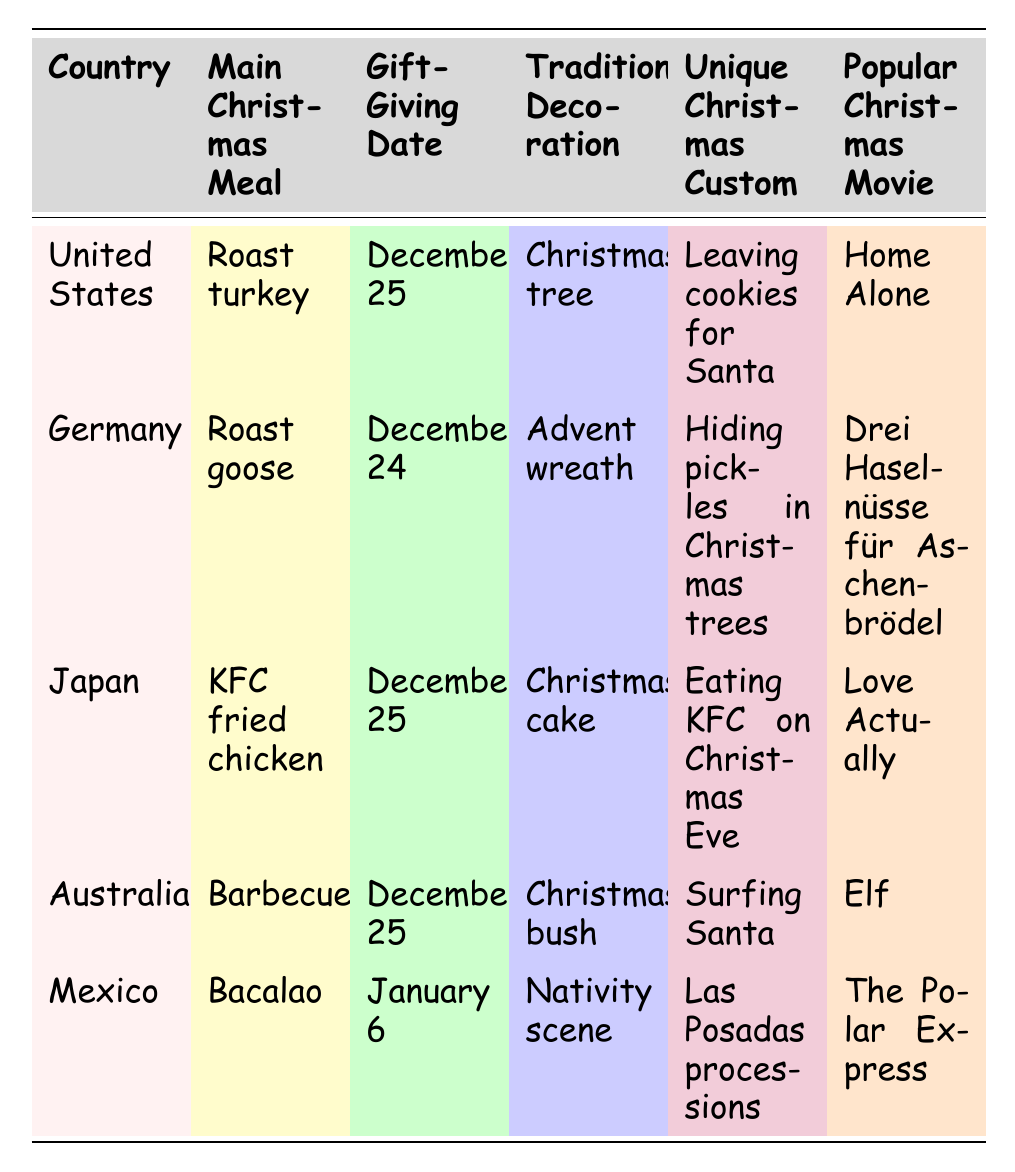What is the main Christmas meal in Germany? The table lists Germany's main Christmas meal as roast goose.
Answer: Roast goose On which date is Christmas gift-giving celebrated in Australia? According to the table, Australia celebrates gift-giving on December 25.
Answer: December 25 What unique Christmas custom does Japan have? The table states that Japan's unique Christmas custom is eating KFC on Christmas Eve.
Answer: Eating KFC on Christmas Eve Which country has a Christmas tree as their traditional decoration? The table shows that the United States uses a Christmas tree as their traditional decoration.
Answer: United States How many countries celebrate gift-giving on December 25? The countries celebrating on December 25 are the United States, Japan, and Australia, totaling three countries.
Answer: Three Is "Las Posadas processions" a unique Christmas custom in Mexico? Yes, the table confirms that "Las Posadas processions" is indeed a unique custom in Mexico.
Answer: Yes Which popular Christmas movie is associated with Germany? From the table, the popular Christmas movie associated with Germany is "Drei Haselnüsse für Aschenbrödel."
Answer: Drei Haselnüsse für Aschenbrödel What is the difference in gift-giving dates between Germany and Mexico? Germany celebrates gift-giving on December 24, while Mexico does so on January 6, making the difference 13 days.
Answer: 13 days Which country has the earliest gift-giving date? Germany, with a gift-giving date of December 24, has the earliest date compared to the other countries listed.
Answer: Germany Is there a country that primarily celebrates Christmas with a barbecue? Yes, Australia celebrates Christmas with a barbecue as their main meal.
Answer: Yes Which country features a unique custom of hiding pickles in Christmas trees? Germany features a unique custom of hiding pickles in Christmas trees, as indicated in the table.
Answer: Germany What is the average main Christmas meal among the listed countries? The main meals include roast turkey, roast goose, KFC fried chicken, barbecue, and bacalao. Taking an average is not applicable as these are not numerical values, but they represent five distinct customs.
Answer: Not applicable Which two countries celebrate Christmas with a specific meal on December 25? The United States and Japan both celebrate Christmas with their main meals on December 25 according to the table.
Answer: United States and Japan How many popular Christmas movies are mentioned in the table? The table lists one popular Christmas movie for each of the five countries, meaning there are five movies mentioned.
Answer: Five 